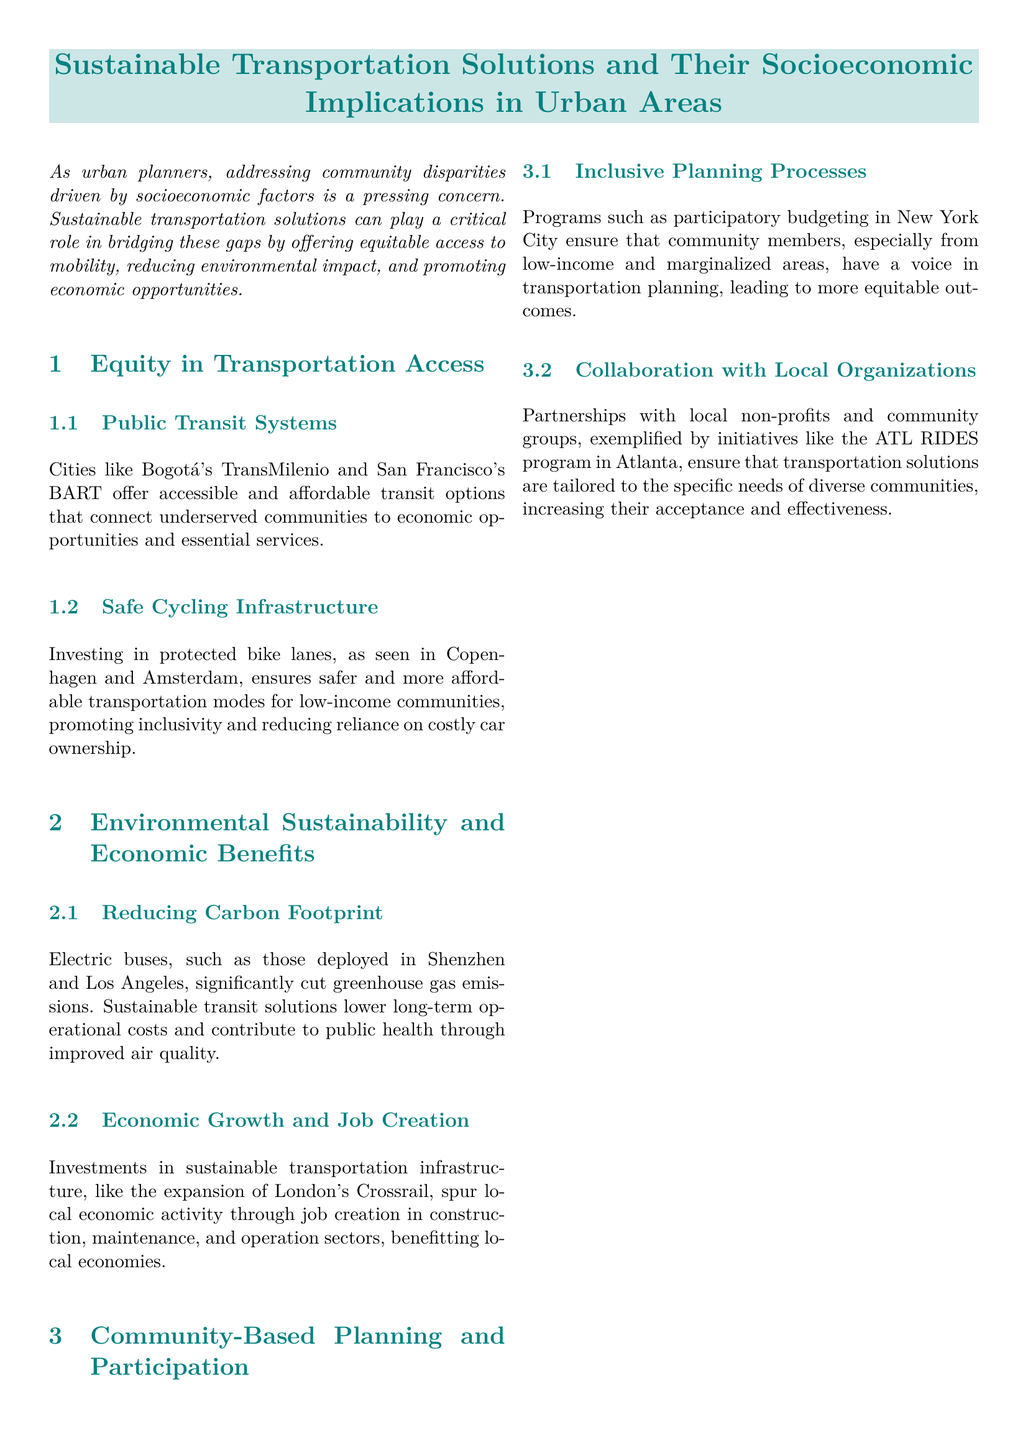What are two examples of cities with effective public transit systems? The document mentions Bogotá's TransMilenio and San Francisco's BART as effective public transit systems that connect underserved communities.
Answer: Bogotá's TransMilenio and San Francisco's BART What is the main benefit of investing in protected bike lanes? The document states that protected bike lanes ensure safer and more affordable transportation modes for low-income communities.
Answer: Safer and more affordable transportation What are two environmental benefits of electric buses? The text highlights that electric buses significantly cut greenhouse gas emissions and improve air quality.
Answer: Cut greenhouse gas emissions and improve air quality Name one sustainable transportation project that spurs local economic activity. The document refers to the expansion of London's Crossrail as a project that spurs local economic activity.
Answer: London’s Crossrail What planning process ensures community voices in transportation decisions? Participatory budgeting in New York City is mentioned as a program that involves community members in transportation planning.
Answer: Participatory budgeting What is a strategy to tailor transportation solutions to community needs? The document illustrates that partnerships with local non-profits and community groups ensure transportation solutions are tailored to diverse community needs.
Answer: Partnerships with local non-profits What does the conclusion emphasize about sustainable transportation solutions? The conclusion states that sustainable transportation solutions are integral to mitigating socioeconomic disparities in urban areas.
Answer: Mitigating socioeconomic disparities What does the document suggest about job creation in sustainable transportation initiatives? It indicates that investments in sustainable transportation infrastructure spur job creation in sectors such as construction and maintenance.
Answer: Spur job creation in construction and maintenance 